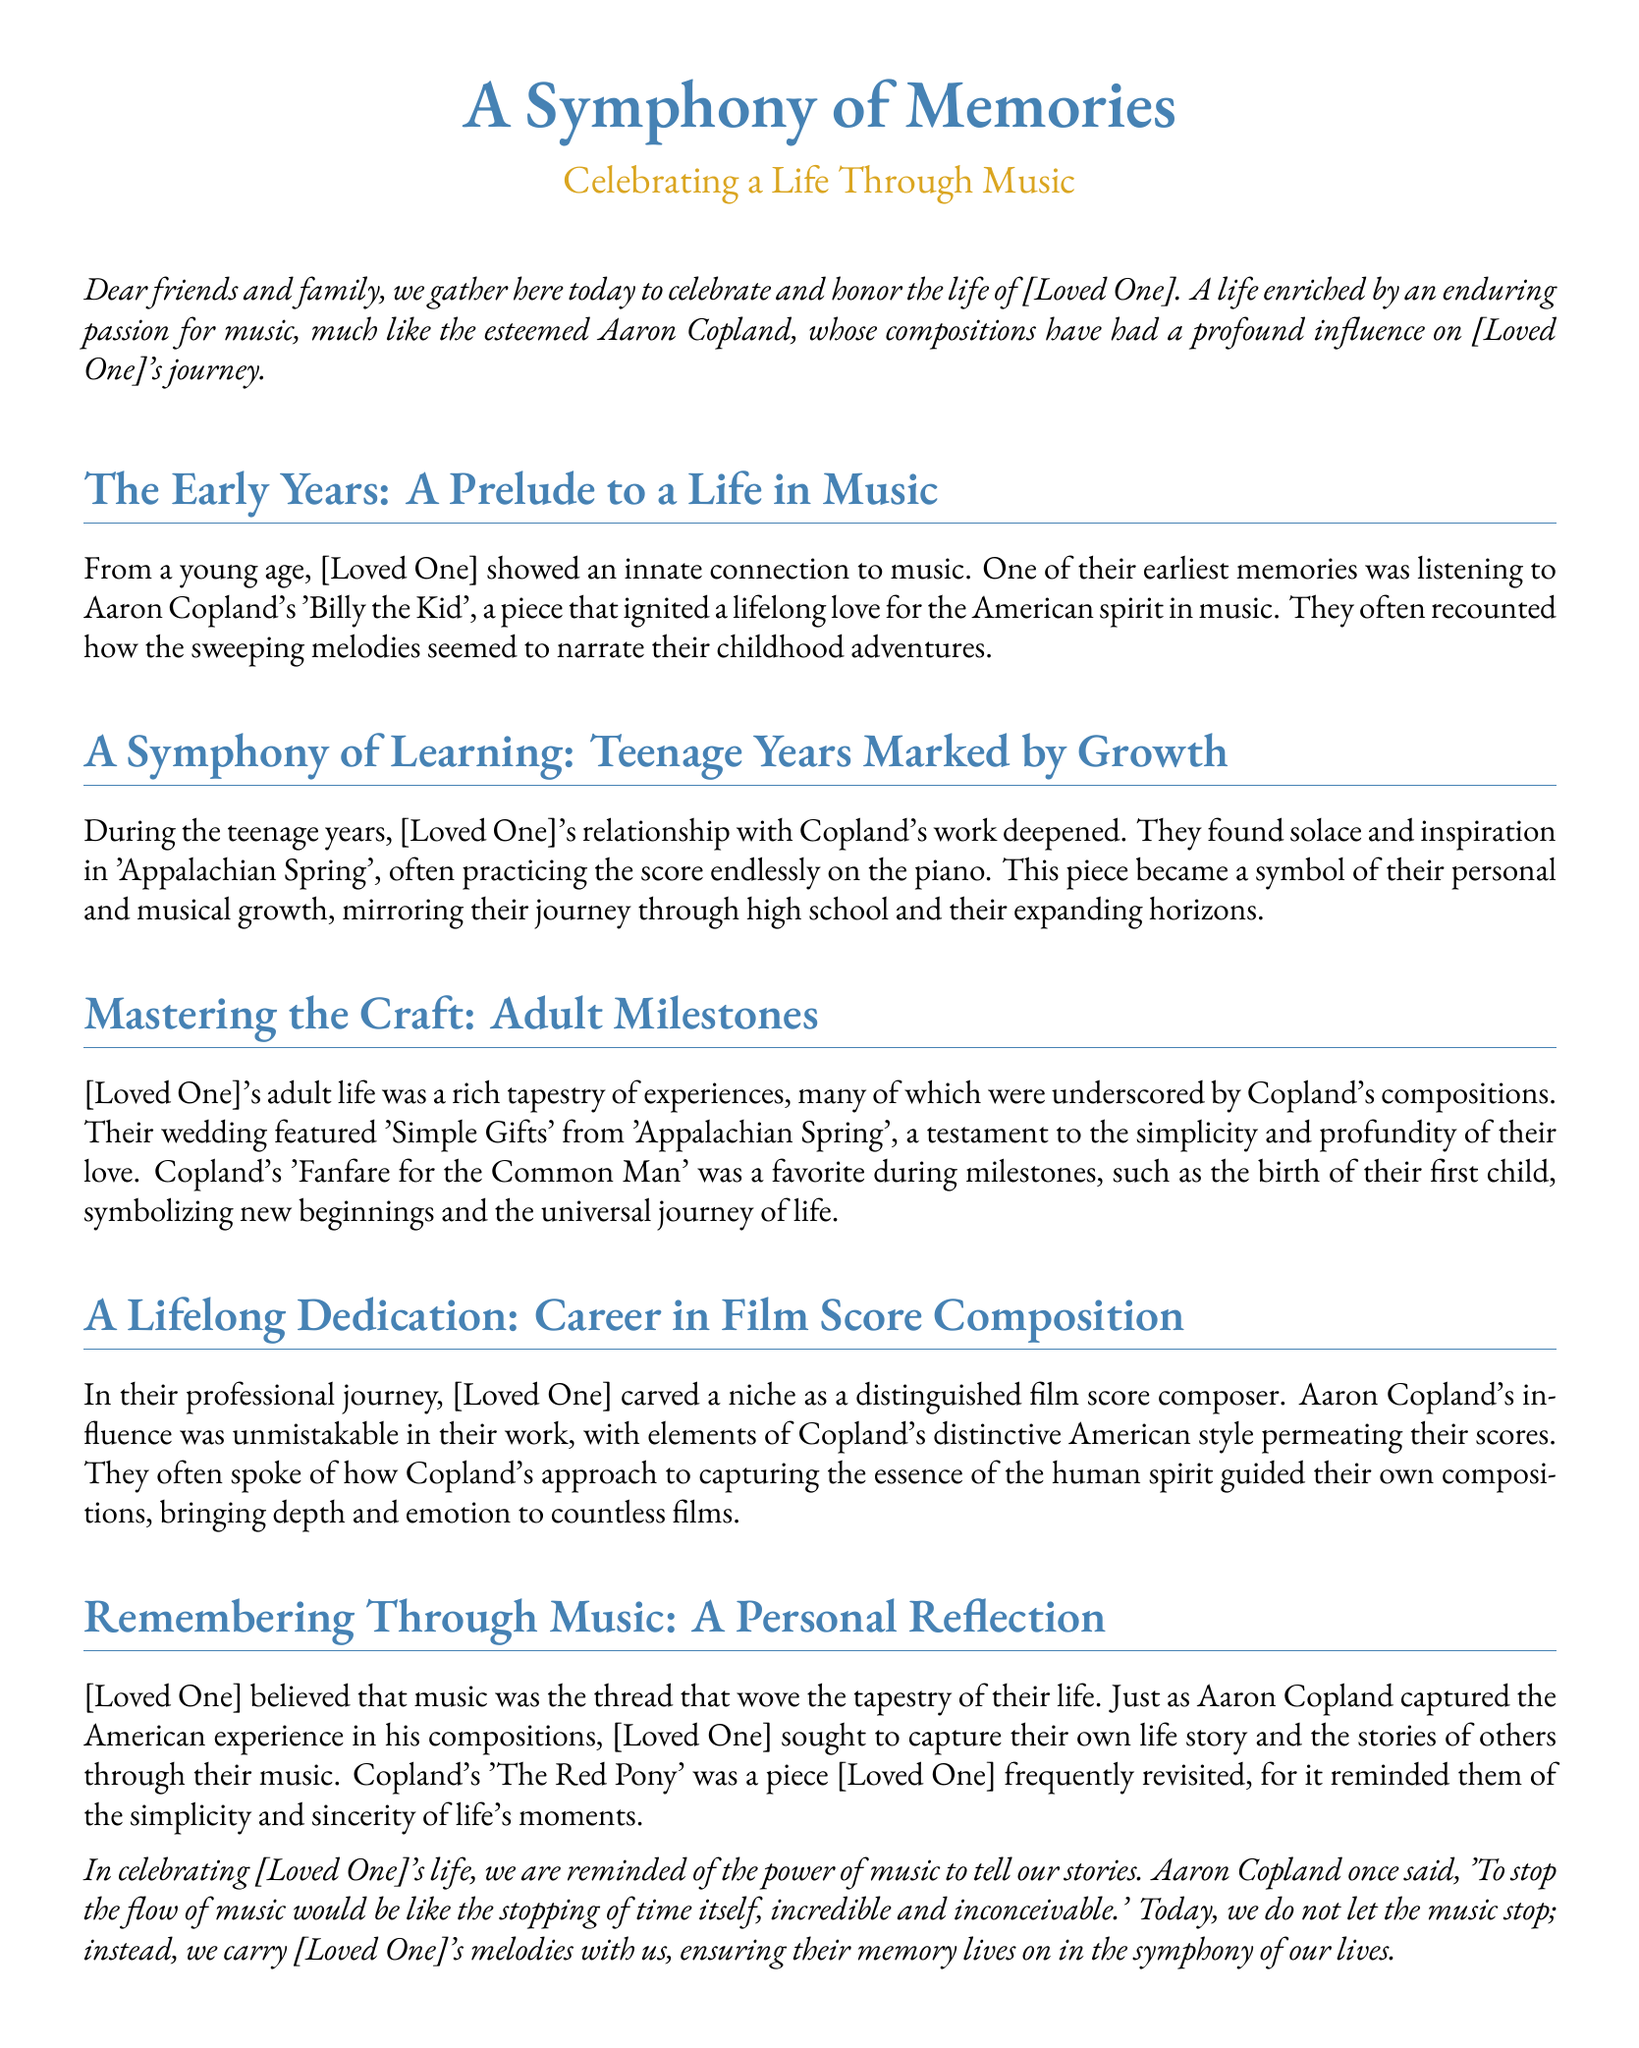what is the title of the eulogy? The title is explicitly mentioned at the beginning of the document.
Answer: A Symphony of Memories who is the composer referenced in the eulogy? The document mentions the esteemed composer whose works influenced the loved one.
Answer: Aaron Copland which piece did [Loved One] listen to as a child? The document specifies an early musical piece that influenced [Loved One] in their childhood.
Answer: Billy the Kid what symbolized [Loved One]'s personal and musical growth during their teenage years? The document refers to a specific composition that represented this growth.
Answer: Appalachian Spring what piece was featured at [Loved One]'s wedding? The document states a specific piece that was played during the wedding ceremony.
Answer: Simple Gifts which composition represented new beginnings in [Loved One]'s life? The document highlights a particular work by Copland that symbolizes new beginnings.
Answer: Fanfare for the Common Man what was [Loved One]'s professional niche? The document describes the area where [Loved One] excelled in their career.
Answer: Film score composition which Copland piece did [Loved One] frequently revisit? The document identifies a specific work that [Loved One] often reflected upon.
Answer: The Red Pony what did [Loved One] believe music was? The document reflects [Loved One]’s perspective on the role of music in their life.
Answer: The thread that wove the tapestry of their life 